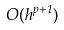Convert formula to latex. <formula><loc_0><loc_0><loc_500><loc_500>O ( h ^ { p + 1 } )</formula> 